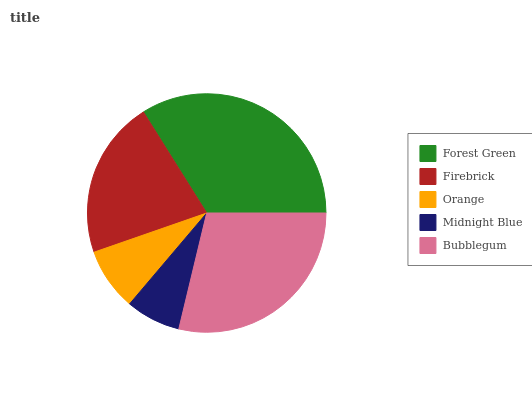Is Midnight Blue the minimum?
Answer yes or no. Yes. Is Forest Green the maximum?
Answer yes or no. Yes. Is Firebrick the minimum?
Answer yes or no. No. Is Firebrick the maximum?
Answer yes or no. No. Is Forest Green greater than Firebrick?
Answer yes or no. Yes. Is Firebrick less than Forest Green?
Answer yes or no. Yes. Is Firebrick greater than Forest Green?
Answer yes or no. No. Is Forest Green less than Firebrick?
Answer yes or no. No. Is Firebrick the high median?
Answer yes or no. Yes. Is Firebrick the low median?
Answer yes or no. Yes. Is Orange the high median?
Answer yes or no. No. Is Midnight Blue the low median?
Answer yes or no. No. 